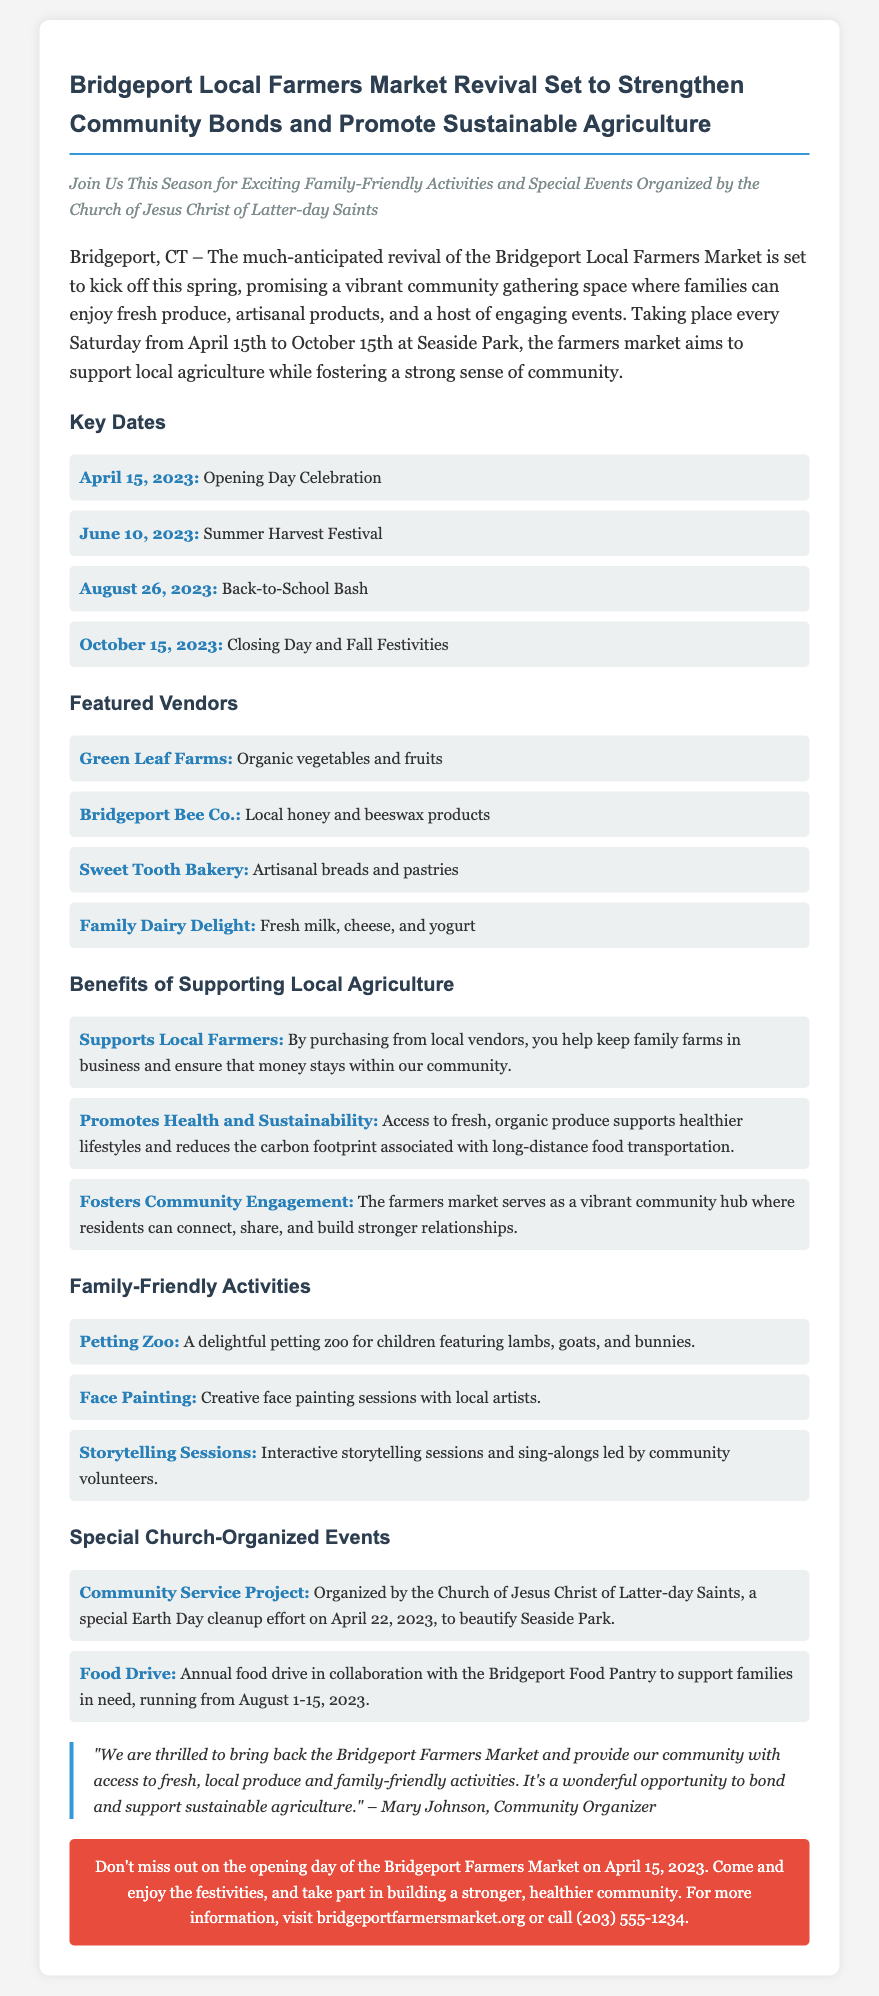What are the opening day and closing day dates for the market? The opening day is April 15, 2023, and the closing day is October 15, 2023.
Answer: April 15, 2023; October 15, 2023 Which vendor offers local honey and beeswax products? The vendor that offers local honey and beeswax products is Bridgeport Bee Co.
Answer: Bridgeport Bee Co What type of activities are available for children at the farmers market? The family-friendly activities include a petting zoo, face painting, and storytelling sessions.
Answer: Petting zoo, face painting, storytelling sessions What is one benefit of supporting local agriculture mentioned in the document? One benefit mentioned is that purchasing from local vendors supports local farmers.
Answer: Supports Local Farmers When is the community service project organized by the Church of Jesus Christ of Latter-day Saints? The community service project is scheduled for April 22, 2023.
Answer: April 22, 2023 How many special events organized by the church are listed? There are two special church-organized events mentioned in the document.
Answer: Two 